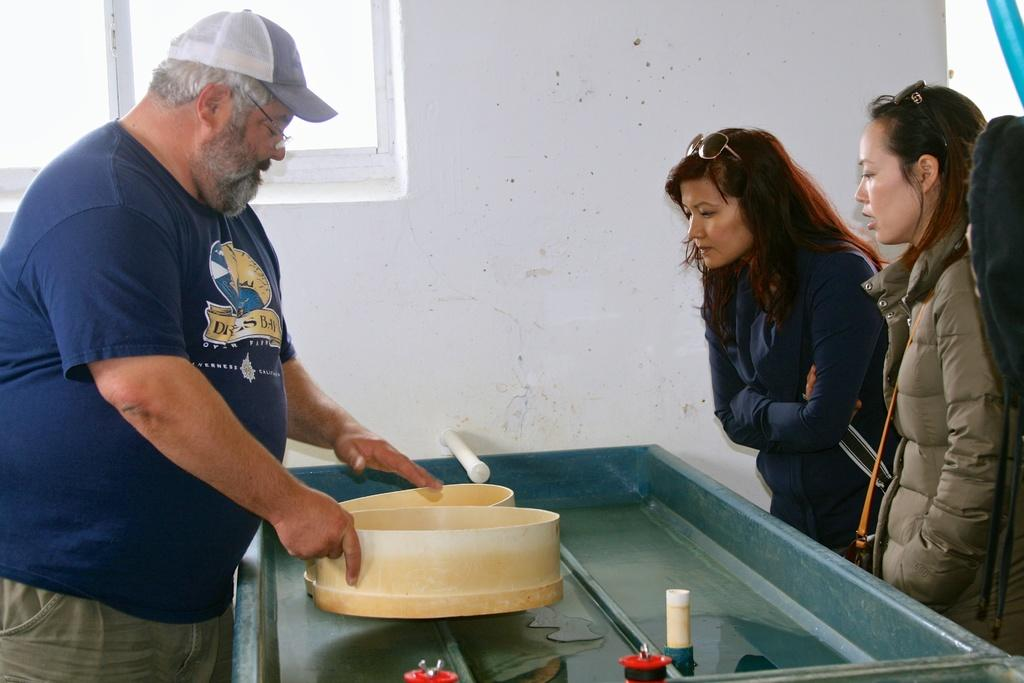How many people are in the image? There is a man and two women in the image. What are the people in the image doing? The man and women are standing. What can be seen in the middle of the image? There is an object or element present in the middle of the image. What is visible in the background of the image? There is a wall and a window in the background of the image. How many rings can be seen on the nest in the image? There is no nest or rings present in the image. 